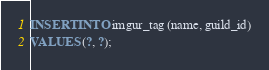Convert code to text. <code><loc_0><loc_0><loc_500><loc_500><_SQL_>INSERT INTO imgur_tag (name, guild_id)
VALUES (?, ?);</code> 